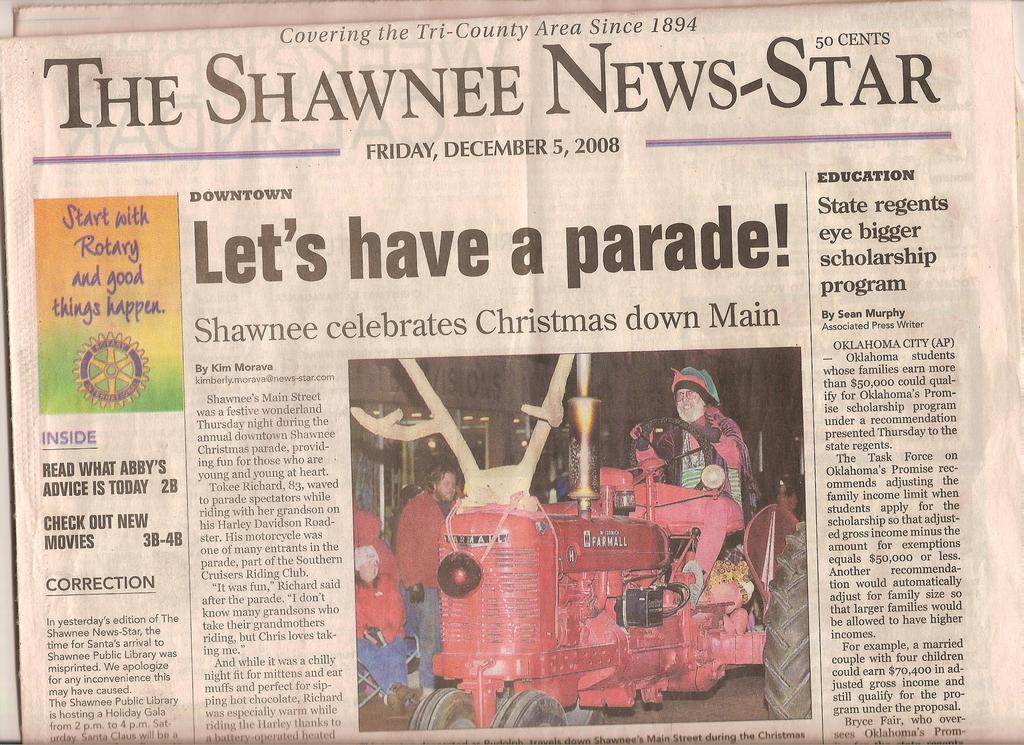<image>
Summarize the visual content of the image. A copy of a Shawnee News-Star newspaper on the front page. 